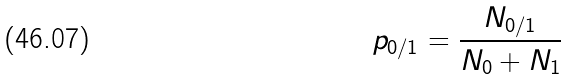<formula> <loc_0><loc_0><loc_500><loc_500>p _ { 0 / 1 } = \frac { N _ { 0 / 1 } } { N _ { 0 } + N _ { 1 } }</formula> 